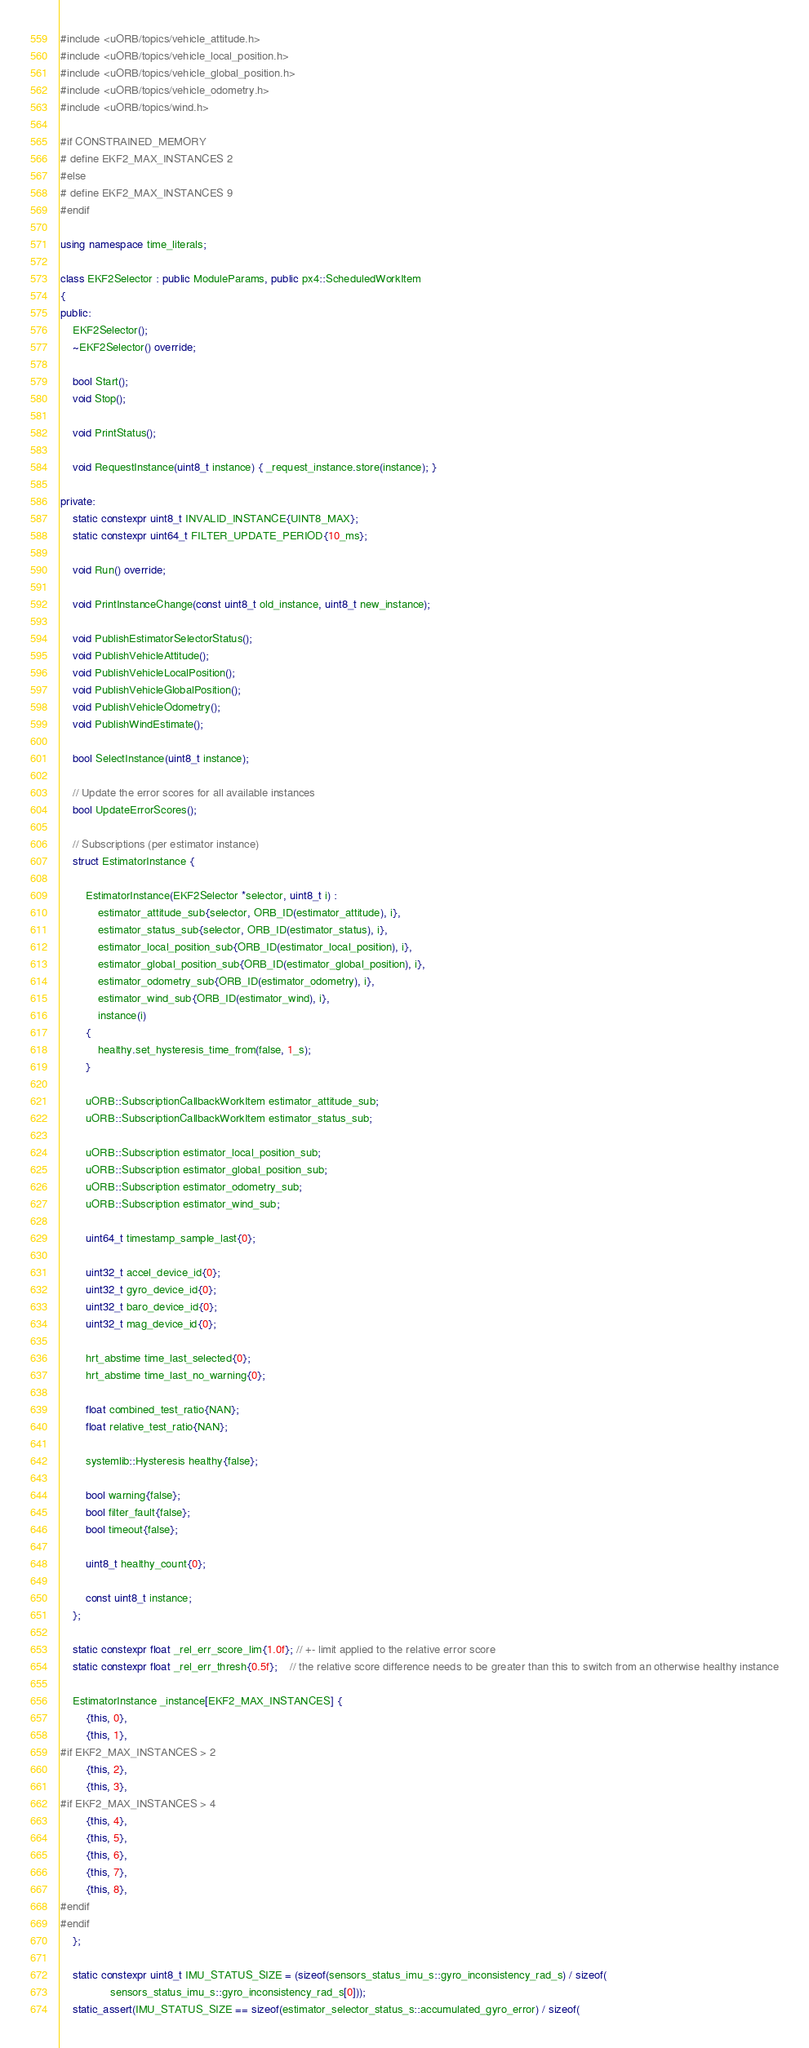<code> <loc_0><loc_0><loc_500><loc_500><_C++_>#include <uORB/topics/vehicle_attitude.h>
#include <uORB/topics/vehicle_local_position.h>
#include <uORB/topics/vehicle_global_position.h>
#include <uORB/topics/vehicle_odometry.h>
#include <uORB/topics/wind.h>

#if CONSTRAINED_MEMORY
# define EKF2_MAX_INSTANCES 2
#else
# define EKF2_MAX_INSTANCES 9
#endif

using namespace time_literals;

class EKF2Selector : public ModuleParams, public px4::ScheduledWorkItem
{
public:
	EKF2Selector();
	~EKF2Selector() override;

	bool Start();
	void Stop();

	void PrintStatus();

	void RequestInstance(uint8_t instance) { _request_instance.store(instance); }

private:
	static constexpr uint8_t INVALID_INSTANCE{UINT8_MAX};
	static constexpr uint64_t FILTER_UPDATE_PERIOD{10_ms};

	void Run() override;

	void PrintInstanceChange(const uint8_t old_instance, uint8_t new_instance);

	void PublishEstimatorSelectorStatus();
	void PublishVehicleAttitude();
	void PublishVehicleLocalPosition();
	void PublishVehicleGlobalPosition();
	void PublishVehicleOdometry();
	void PublishWindEstimate();

	bool SelectInstance(uint8_t instance);

	// Update the error scores for all available instances
	bool UpdateErrorScores();

	// Subscriptions (per estimator instance)
	struct EstimatorInstance {

		EstimatorInstance(EKF2Selector *selector, uint8_t i) :
			estimator_attitude_sub{selector, ORB_ID(estimator_attitude), i},
			estimator_status_sub{selector, ORB_ID(estimator_status), i},
			estimator_local_position_sub{ORB_ID(estimator_local_position), i},
			estimator_global_position_sub{ORB_ID(estimator_global_position), i},
			estimator_odometry_sub{ORB_ID(estimator_odometry), i},
			estimator_wind_sub{ORB_ID(estimator_wind), i},
			instance(i)
		{
			healthy.set_hysteresis_time_from(false, 1_s);
		}

		uORB::SubscriptionCallbackWorkItem estimator_attitude_sub;
		uORB::SubscriptionCallbackWorkItem estimator_status_sub;

		uORB::Subscription estimator_local_position_sub;
		uORB::Subscription estimator_global_position_sub;
		uORB::Subscription estimator_odometry_sub;
		uORB::Subscription estimator_wind_sub;

		uint64_t timestamp_sample_last{0};

		uint32_t accel_device_id{0};
		uint32_t gyro_device_id{0};
		uint32_t baro_device_id{0};
		uint32_t mag_device_id{0};

		hrt_abstime time_last_selected{0};
		hrt_abstime time_last_no_warning{0};

		float combined_test_ratio{NAN};
		float relative_test_ratio{NAN};

		systemlib::Hysteresis healthy{false};

		bool warning{false};
		bool filter_fault{false};
		bool timeout{false};

		uint8_t healthy_count{0};

		const uint8_t instance;
	};

	static constexpr float _rel_err_score_lim{1.0f}; // +- limit applied to the relative error score
	static constexpr float _rel_err_thresh{0.5f};    // the relative score difference needs to be greater than this to switch from an otherwise healthy instance

	EstimatorInstance _instance[EKF2_MAX_INSTANCES] {
		{this, 0},
		{this, 1},
#if EKF2_MAX_INSTANCES > 2
		{this, 2},
		{this, 3},
#if EKF2_MAX_INSTANCES > 4
		{this, 4},
		{this, 5},
		{this, 6},
		{this, 7},
		{this, 8},
#endif
#endif
	};

	static constexpr uint8_t IMU_STATUS_SIZE = (sizeof(sensors_status_imu_s::gyro_inconsistency_rad_s) / sizeof(
				sensors_status_imu_s::gyro_inconsistency_rad_s[0]));
	static_assert(IMU_STATUS_SIZE == sizeof(estimator_selector_status_s::accumulated_gyro_error) / sizeof(</code> 